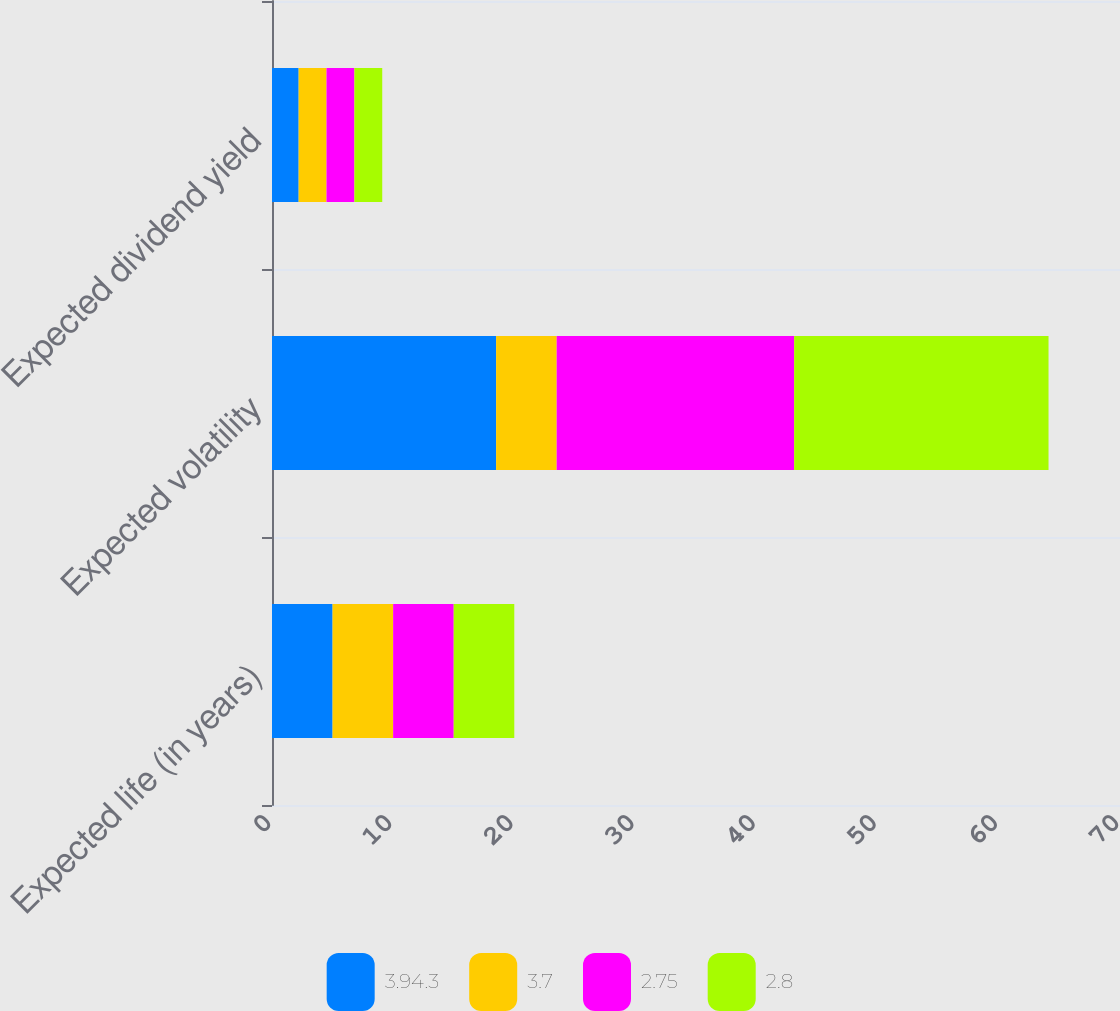<chart> <loc_0><loc_0><loc_500><loc_500><stacked_bar_chart><ecel><fcel>Expected life (in years)<fcel>Expected volatility<fcel>Expected dividend yield<nl><fcel>3.94.3<fcel>5<fcel>18.5<fcel>2.2<nl><fcel>3.7<fcel>5<fcel>5<fcel>2.3<nl><fcel>2.75<fcel>5<fcel>19.6<fcel>2.3<nl><fcel>2.8<fcel>5<fcel>21<fcel>2.3<nl></chart> 